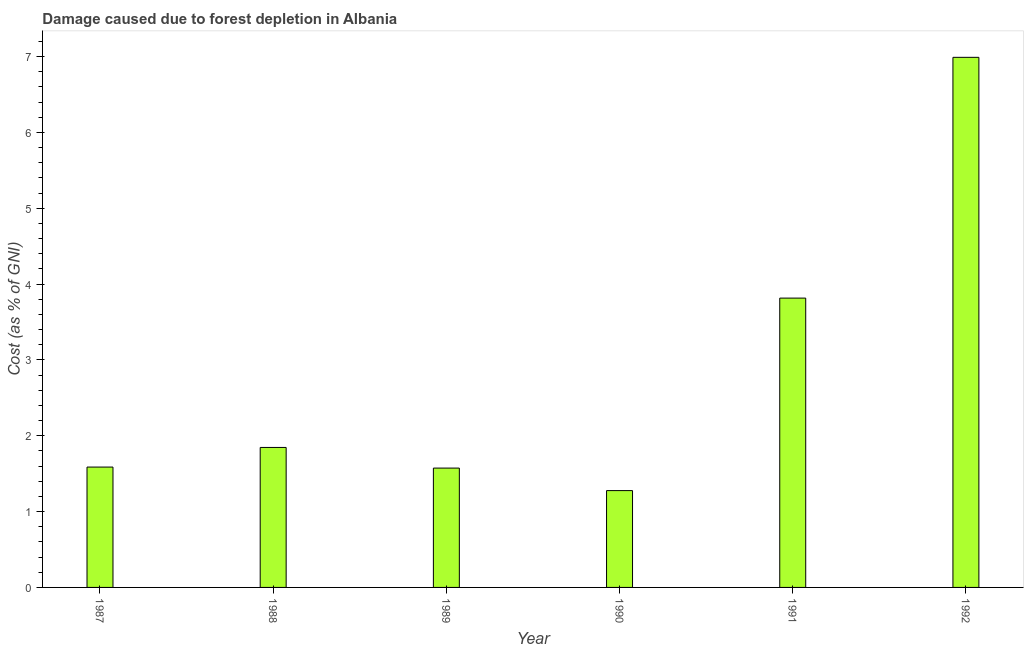Does the graph contain any zero values?
Keep it short and to the point. No. What is the title of the graph?
Your answer should be very brief. Damage caused due to forest depletion in Albania. What is the label or title of the X-axis?
Provide a succinct answer. Year. What is the label or title of the Y-axis?
Offer a very short reply. Cost (as % of GNI). What is the damage caused due to forest depletion in 1991?
Your answer should be very brief. 3.82. Across all years, what is the maximum damage caused due to forest depletion?
Keep it short and to the point. 6.99. Across all years, what is the minimum damage caused due to forest depletion?
Give a very brief answer. 1.28. In which year was the damage caused due to forest depletion minimum?
Ensure brevity in your answer.  1990. What is the sum of the damage caused due to forest depletion?
Make the answer very short. 17.09. What is the difference between the damage caused due to forest depletion in 1987 and 1989?
Your response must be concise. 0.01. What is the average damage caused due to forest depletion per year?
Keep it short and to the point. 2.85. What is the median damage caused due to forest depletion?
Give a very brief answer. 1.72. In how many years, is the damage caused due to forest depletion greater than 5.2 %?
Give a very brief answer. 1. What is the ratio of the damage caused due to forest depletion in 1987 to that in 1992?
Keep it short and to the point. 0.23. Is the difference between the damage caused due to forest depletion in 1987 and 1989 greater than the difference between any two years?
Your answer should be compact. No. What is the difference between the highest and the second highest damage caused due to forest depletion?
Make the answer very short. 3.17. Is the sum of the damage caused due to forest depletion in 1990 and 1991 greater than the maximum damage caused due to forest depletion across all years?
Your answer should be compact. No. What is the difference between the highest and the lowest damage caused due to forest depletion?
Provide a succinct answer. 5.71. In how many years, is the damage caused due to forest depletion greater than the average damage caused due to forest depletion taken over all years?
Keep it short and to the point. 2. Are all the bars in the graph horizontal?
Ensure brevity in your answer.  No. How many years are there in the graph?
Offer a very short reply. 6. What is the difference between two consecutive major ticks on the Y-axis?
Your answer should be very brief. 1. What is the Cost (as % of GNI) in 1987?
Make the answer very short. 1.59. What is the Cost (as % of GNI) of 1988?
Offer a terse response. 1.85. What is the Cost (as % of GNI) of 1989?
Provide a succinct answer. 1.57. What is the Cost (as % of GNI) of 1990?
Make the answer very short. 1.28. What is the Cost (as % of GNI) in 1991?
Provide a succinct answer. 3.82. What is the Cost (as % of GNI) in 1992?
Offer a terse response. 6.99. What is the difference between the Cost (as % of GNI) in 1987 and 1988?
Give a very brief answer. -0.26. What is the difference between the Cost (as % of GNI) in 1987 and 1989?
Give a very brief answer. 0.01. What is the difference between the Cost (as % of GNI) in 1987 and 1990?
Make the answer very short. 0.31. What is the difference between the Cost (as % of GNI) in 1987 and 1991?
Ensure brevity in your answer.  -2.23. What is the difference between the Cost (as % of GNI) in 1987 and 1992?
Your answer should be compact. -5.4. What is the difference between the Cost (as % of GNI) in 1988 and 1989?
Offer a terse response. 0.27. What is the difference between the Cost (as % of GNI) in 1988 and 1990?
Ensure brevity in your answer.  0.57. What is the difference between the Cost (as % of GNI) in 1988 and 1991?
Offer a terse response. -1.97. What is the difference between the Cost (as % of GNI) in 1988 and 1992?
Your answer should be compact. -5.14. What is the difference between the Cost (as % of GNI) in 1989 and 1990?
Keep it short and to the point. 0.3. What is the difference between the Cost (as % of GNI) in 1989 and 1991?
Offer a very short reply. -2.24. What is the difference between the Cost (as % of GNI) in 1989 and 1992?
Keep it short and to the point. -5.42. What is the difference between the Cost (as % of GNI) in 1990 and 1991?
Provide a short and direct response. -2.54. What is the difference between the Cost (as % of GNI) in 1990 and 1992?
Your answer should be compact. -5.71. What is the difference between the Cost (as % of GNI) in 1991 and 1992?
Ensure brevity in your answer.  -3.18. What is the ratio of the Cost (as % of GNI) in 1987 to that in 1988?
Your response must be concise. 0.86. What is the ratio of the Cost (as % of GNI) in 1987 to that in 1990?
Ensure brevity in your answer.  1.24. What is the ratio of the Cost (as % of GNI) in 1987 to that in 1991?
Ensure brevity in your answer.  0.42. What is the ratio of the Cost (as % of GNI) in 1987 to that in 1992?
Make the answer very short. 0.23. What is the ratio of the Cost (as % of GNI) in 1988 to that in 1989?
Give a very brief answer. 1.17. What is the ratio of the Cost (as % of GNI) in 1988 to that in 1990?
Keep it short and to the point. 1.45. What is the ratio of the Cost (as % of GNI) in 1988 to that in 1991?
Keep it short and to the point. 0.48. What is the ratio of the Cost (as % of GNI) in 1988 to that in 1992?
Keep it short and to the point. 0.26. What is the ratio of the Cost (as % of GNI) in 1989 to that in 1990?
Offer a terse response. 1.23. What is the ratio of the Cost (as % of GNI) in 1989 to that in 1991?
Your response must be concise. 0.41. What is the ratio of the Cost (as % of GNI) in 1989 to that in 1992?
Provide a succinct answer. 0.23. What is the ratio of the Cost (as % of GNI) in 1990 to that in 1991?
Ensure brevity in your answer.  0.34. What is the ratio of the Cost (as % of GNI) in 1990 to that in 1992?
Offer a terse response. 0.18. What is the ratio of the Cost (as % of GNI) in 1991 to that in 1992?
Provide a short and direct response. 0.55. 